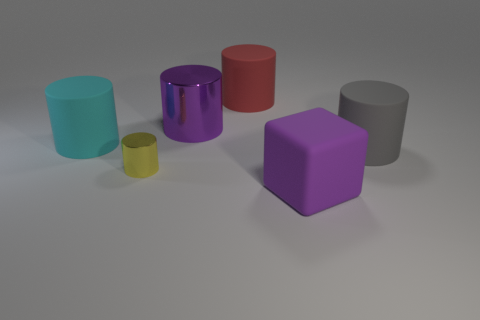Is the number of cyan things to the left of the tiny yellow shiny thing greater than the number of big purple cylinders that are in front of the red matte cylinder?
Offer a very short reply. No. Does the cyan matte cylinder have the same size as the yellow metal cylinder?
Your response must be concise. No. What color is the other small metallic object that is the same shape as the cyan object?
Provide a succinct answer. Yellow. What number of other objects have the same color as the tiny metal object?
Make the answer very short. 0. Are there more small metal cylinders left of the big cyan rubber cylinder than big cyan metal balls?
Make the answer very short. No. What color is the big rubber cylinder that is on the right side of the big rubber cylinder that is behind the large cyan matte cylinder?
Provide a short and direct response. Gray. How many objects are large purple things that are right of the purple shiny cylinder or shiny objects left of the gray object?
Make the answer very short. 3. The big metallic object is what color?
Your answer should be compact. Purple. How many large red blocks are made of the same material as the big cyan cylinder?
Provide a succinct answer. 0. Is the number of big red spheres greater than the number of tiny yellow metal things?
Keep it short and to the point. No. 